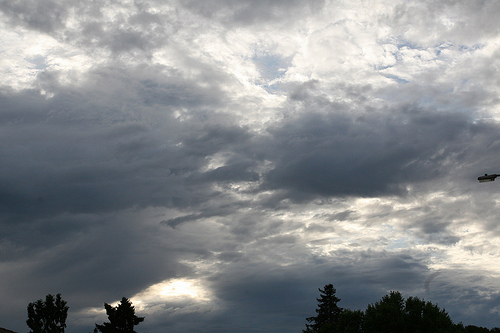<image>
Can you confirm if the sky is behind the tree? Yes. From this viewpoint, the sky is positioned behind the tree, with the tree partially or fully occluding the sky. Is there a tree next to the cloud? No. The tree is not positioned next to the cloud. They are located in different areas of the scene. 